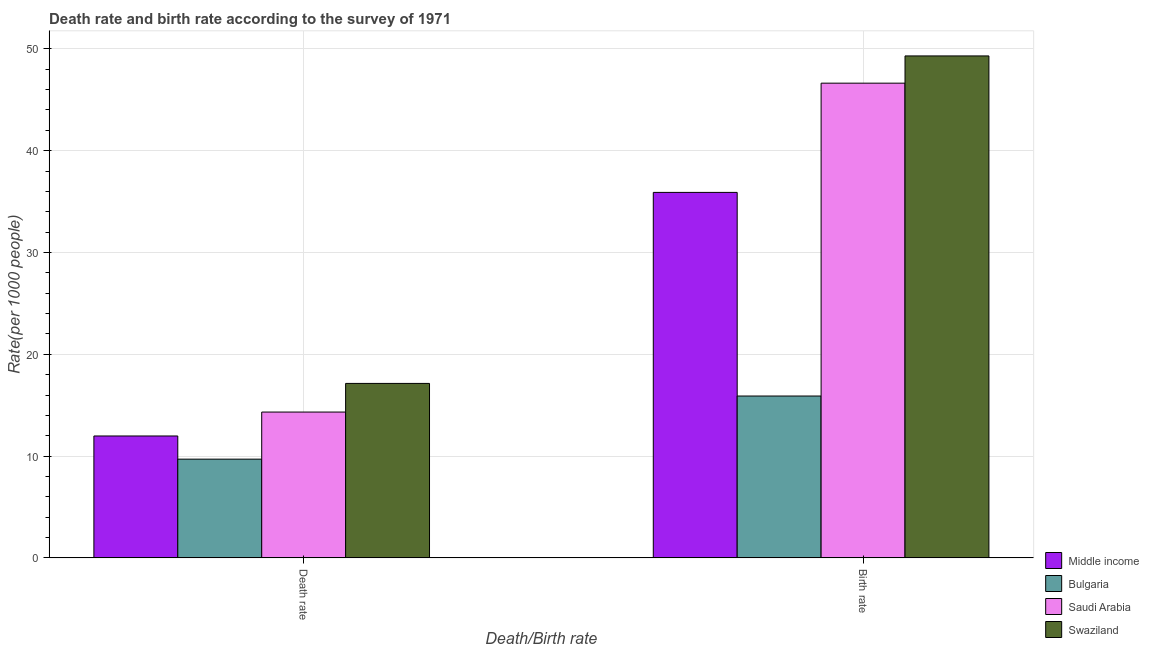How many groups of bars are there?
Give a very brief answer. 2. Are the number of bars per tick equal to the number of legend labels?
Give a very brief answer. Yes. Are the number of bars on each tick of the X-axis equal?
Provide a succinct answer. Yes. How many bars are there on the 1st tick from the left?
Your answer should be compact. 4. What is the label of the 2nd group of bars from the left?
Make the answer very short. Birth rate. What is the death rate in Middle income?
Keep it short and to the point. 11.97. Across all countries, what is the maximum birth rate?
Keep it short and to the point. 49.3. In which country was the birth rate maximum?
Keep it short and to the point. Swaziland. In which country was the birth rate minimum?
Give a very brief answer. Bulgaria. What is the total death rate in the graph?
Provide a short and direct response. 53.14. What is the difference between the death rate in Middle income and that in Saudi Arabia?
Your answer should be very brief. -2.35. What is the difference between the birth rate in Swaziland and the death rate in Bulgaria?
Your response must be concise. 39.61. What is the average birth rate per country?
Give a very brief answer. 36.93. What is the difference between the birth rate and death rate in Bulgaria?
Ensure brevity in your answer.  6.2. What is the ratio of the death rate in Middle income to that in Swaziland?
Provide a short and direct response. 0.7. Is the birth rate in Bulgaria less than that in Swaziland?
Provide a short and direct response. Yes. What does the 2nd bar from the left in Birth rate represents?
Your answer should be very brief. Bulgaria. How many countries are there in the graph?
Keep it short and to the point. 4. Are the values on the major ticks of Y-axis written in scientific E-notation?
Provide a short and direct response. No. Does the graph contain any zero values?
Your response must be concise. No. Where does the legend appear in the graph?
Your response must be concise. Bottom right. How are the legend labels stacked?
Your response must be concise. Vertical. What is the title of the graph?
Make the answer very short. Death rate and birth rate according to the survey of 1971. Does "Morocco" appear as one of the legend labels in the graph?
Provide a short and direct response. No. What is the label or title of the X-axis?
Keep it short and to the point. Death/Birth rate. What is the label or title of the Y-axis?
Your response must be concise. Rate(per 1000 people). What is the Rate(per 1000 people) in Middle income in Death rate?
Keep it short and to the point. 11.97. What is the Rate(per 1000 people) of Saudi Arabia in Death rate?
Your response must be concise. 14.32. What is the Rate(per 1000 people) in Swaziland in Death rate?
Your answer should be very brief. 17.14. What is the Rate(per 1000 people) in Middle income in Birth rate?
Make the answer very short. 35.9. What is the Rate(per 1000 people) of Bulgaria in Birth rate?
Provide a succinct answer. 15.9. What is the Rate(per 1000 people) in Saudi Arabia in Birth rate?
Offer a terse response. 46.63. What is the Rate(per 1000 people) of Swaziland in Birth rate?
Make the answer very short. 49.3. Across all Death/Birth rate, what is the maximum Rate(per 1000 people) of Middle income?
Offer a terse response. 35.9. Across all Death/Birth rate, what is the maximum Rate(per 1000 people) of Saudi Arabia?
Provide a succinct answer. 46.63. Across all Death/Birth rate, what is the maximum Rate(per 1000 people) of Swaziland?
Your answer should be compact. 49.3. Across all Death/Birth rate, what is the minimum Rate(per 1000 people) of Middle income?
Make the answer very short. 11.97. Across all Death/Birth rate, what is the minimum Rate(per 1000 people) of Bulgaria?
Your response must be concise. 9.7. Across all Death/Birth rate, what is the minimum Rate(per 1000 people) of Saudi Arabia?
Your answer should be compact. 14.32. Across all Death/Birth rate, what is the minimum Rate(per 1000 people) of Swaziland?
Keep it short and to the point. 17.14. What is the total Rate(per 1000 people) in Middle income in the graph?
Offer a very short reply. 47.88. What is the total Rate(per 1000 people) of Bulgaria in the graph?
Your answer should be very brief. 25.6. What is the total Rate(per 1000 people) of Saudi Arabia in the graph?
Your response must be concise. 60.95. What is the total Rate(per 1000 people) in Swaziland in the graph?
Offer a terse response. 66.44. What is the difference between the Rate(per 1000 people) of Middle income in Death rate and that in Birth rate?
Make the answer very short. -23.93. What is the difference between the Rate(per 1000 people) in Bulgaria in Death rate and that in Birth rate?
Keep it short and to the point. -6.2. What is the difference between the Rate(per 1000 people) in Saudi Arabia in Death rate and that in Birth rate?
Provide a short and direct response. -32.3. What is the difference between the Rate(per 1000 people) of Swaziland in Death rate and that in Birth rate?
Offer a terse response. -32.17. What is the difference between the Rate(per 1000 people) in Middle income in Death rate and the Rate(per 1000 people) in Bulgaria in Birth rate?
Give a very brief answer. -3.92. What is the difference between the Rate(per 1000 people) in Middle income in Death rate and the Rate(per 1000 people) in Saudi Arabia in Birth rate?
Provide a short and direct response. -34.65. What is the difference between the Rate(per 1000 people) in Middle income in Death rate and the Rate(per 1000 people) in Swaziland in Birth rate?
Give a very brief answer. -37.33. What is the difference between the Rate(per 1000 people) in Bulgaria in Death rate and the Rate(per 1000 people) in Saudi Arabia in Birth rate?
Offer a very short reply. -36.93. What is the difference between the Rate(per 1000 people) of Bulgaria in Death rate and the Rate(per 1000 people) of Swaziland in Birth rate?
Keep it short and to the point. -39.6. What is the difference between the Rate(per 1000 people) in Saudi Arabia in Death rate and the Rate(per 1000 people) in Swaziland in Birth rate?
Ensure brevity in your answer.  -34.98. What is the average Rate(per 1000 people) of Middle income per Death/Birth rate?
Provide a succinct answer. 23.94. What is the average Rate(per 1000 people) in Bulgaria per Death/Birth rate?
Your response must be concise. 12.8. What is the average Rate(per 1000 people) of Saudi Arabia per Death/Birth rate?
Your answer should be compact. 30.48. What is the average Rate(per 1000 people) in Swaziland per Death/Birth rate?
Give a very brief answer. 33.22. What is the difference between the Rate(per 1000 people) in Middle income and Rate(per 1000 people) in Bulgaria in Death rate?
Make the answer very short. 2.27. What is the difference between the Rate(per 1000 people) of Middle income and Rate(per 1000 people) of Saudi Arabia in Death rate?
Give a very brief answer. -2.35. What is the difference between the Rate(per 1000 people) in Middle income and Rate(per 1000 people) in Swaziland in Death rate?
Offer a very short reply. -5.16. What is the difference between the Rate(per 1000 people) in Bulgaria and Rate(per 1000 people) in Saudi Arabia in Death rate?
Provide a short and direct response. -4.62. What is the difference between the Rate(per 1000 people) of Bulgaria and Rate(per 1000 people) of Swaziland in Death rate?
Provide a short and direct response. -7.44. What is the difference between the Rate(per 1000 people) of Saudi Arabia and Rate(per 1000 people) of Swaziland in Death rate?
Offer a terse response. -2.81. What is the difference between the Rate(per 1000 people) of Middle income and Rate(per 1000 people) of Bulgaria in Birth rate?
Provide a short and direct response. 20. What is the difference between the Rate(per 1000 people) of Middle income and Rate(per 1000 people) of Saudi Arabia in Birth rate?
Ensure brevity in your answer.  -10.73. What is the difference between the Rate(per 1000 people) in Middle income and Rate(per 1000 people) in Swaziland in Birth rate?
Your answer should be compact. -13.4. What is the difference between the Rate(per 1000 people) of Bulgaria and Rate(per 1000 people) of Saudi Arabia in Birth rate?
Provide a succinct answer. -30.73. What is the difference between the Rate(per 1000 people) in Bulgaria and Rate(per 1000 people) in Swaziland in Birth rate?
Your answer should be compact. -33.41. What is the difference between the Rate(per 1000 people) in Saudi Arabia and Rate(per 1000 people) in Swaziland in Birth rate?
Your answer should be very brief. -2.68. What is the ratio of the Rate(per 1000 people) in Middle income in Death rate to that in Birth rate?
Give a very brief answer. 0.33. What is the ratio of the Rate(per 1000 people) of Bulgaria in Death rate to that in Birth rate?
Keep it short and to the point. 0.61. What is the ratio of the Rate(per 1000 people) in Saudi Arabia in Death rate to that in Birth rate?
Provide a succinct answer. 0.31. What is the ratio of the Rate(per 1000 people) in Swaziland in Death rate to that in Birth rate?
Offer a terse response. 0.35. What is the difference between the highest and the second highest Rate(per 1000 people) in Middle income?
Your answer should be very brief. 23.93. What is the difference between the highest and the second highest Rate(per 1000 people) in Saudi Arabia?
Your answer should be compact. 32.3. What is the difference between the highest and the second highest Rate(per 1000 people) of Swaziland?
Give a very brief answer. 32.17. What is the difference between the highest and the lowest Rate(per 1000 people) in Middle income?
Offer a terse response. 23.93. What is the difference between the highest and the lowest Rate(per 1000 people) of Bulgaria?
Your response must be concise. 6.2. What is the difference between the highest and the lowest Rate(per 1000 people) of Saudi Arabia?
Make the answer very short. 32.3. What is the difference between the highest and the lowest Rate(per 1000 people) in Swaziland?
Your answer should be very brief. 32.17. 